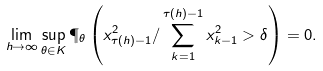Convert formula to latex. <formula><loc_0><loc_0><loc_500><loc_500>\lim _ { h \to \infty } \sup _ { \theta \in K } \P _ { \theta } \left ( x _ { \tau ( h ) - 1 } ^ { 2 } / \sum _ { k = 1 } ^ { \tau ( h ) - 1 } x _ { k - 1 } ^ { 2 } > \delta \right ) = 0 .</formula> 